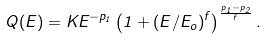Convert formula to latex. <formula><loc_0><loc_0><loc_500><loc_500>Q ( E ) = K E ^ { - p _ { 1 } } \left ( 1 + ( E / E _ { o } ) ^ { f } \right ) ^ { \frac { p _ { 1 } - p _ { 2 } } { f } } .</formula> 